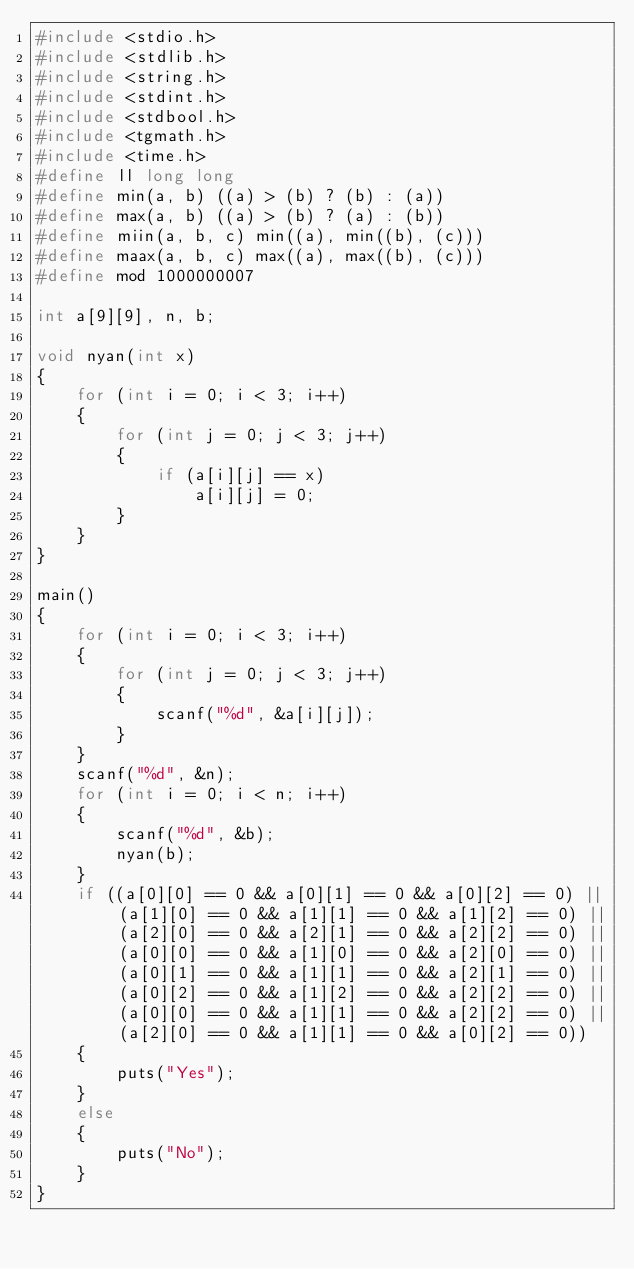<code> <loc_0><loc_0><loc_500><loc_500><_C_>#include <stdio.h>
#include <stdlib.h>
#include <string.h>
#include <stdint.h>
#include <stdbool.h>
#include <tgmath.h>
#include <time.h>
#define ll long long
#define min(a, b) ((a) > (b) ? (b) : (a))
#define max(a, b) ((a) > (b) ? (a) : (b))
#define miin(a, b, c) min((a), min((b), (c)))
#define maax(a, b, c) max((a), max((b), (c)))
#define mod 1000000007

int a[9][9], n, b;

void nyan(int x)
{
    for (int i = 0; i < 3; i++)
    {
        for (int j = 0; j < 3; j++)
        {
            if (a[i][j] == x)
                a[i][j] = 0;
        }
    }
}

main()
{
    for (int i = 0; i < 3; i++)
    {
        for (int j = 0; j < 3; j++)
        {
            scanf("%d", &a[i][j]);
        }
    }
    scanf("%d", &n);
    for (int i = 0; i < n; i++)
    {
        scanf("%d", &b);
        nyan(b);
    }
    if ((a[0][0] == 0 && a[0][1] == 0 && a[0][2] == 0) || (a[1][0] == 0 && a[1][1] == 0 && a[1][2] == 0) || (a[2][0] == 0 && a[2][1] == 0 && a[2][2] == 0) || (a[0][0] == 0 && a[1][0] == 0 && a[2][0] == 0) || (a[0][1] == 0 && a[1][1] == 0 && a[2][1] == 0) || (a[0][2] == 0 && a[1][2] == 0 && a[2][2] == 0) || (a[0][0] == 0 && a[1][1] == 0 && a[2][2] == 0) || (a[2][0] == 0 && a[1][1] == 0 && a[0][2] == 0))
    {
        puts("Yes");
    }
    else
    {
        puts("No");
    }
}</code> 